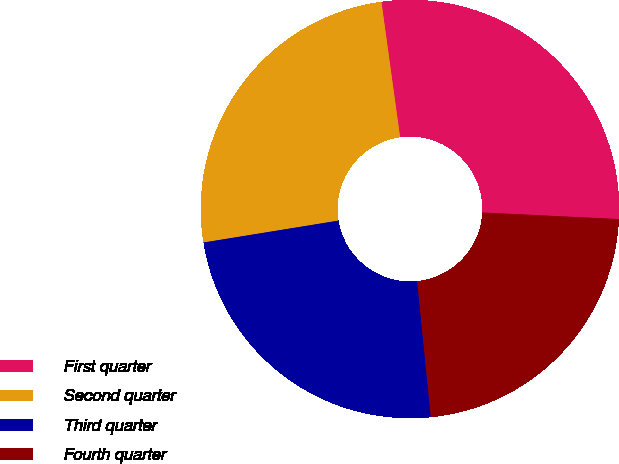<chart> <loc_0><loc_0><loc_500><loc_500><pie_chart><fcel>First quarter<fcel>Second quarter<fcel>Third quarter<fcel>Fourth quarter<nl><fcel>27.95%<fcel>25.38%<fcel>24.03%<fcel>22.64%<nl></chart> 